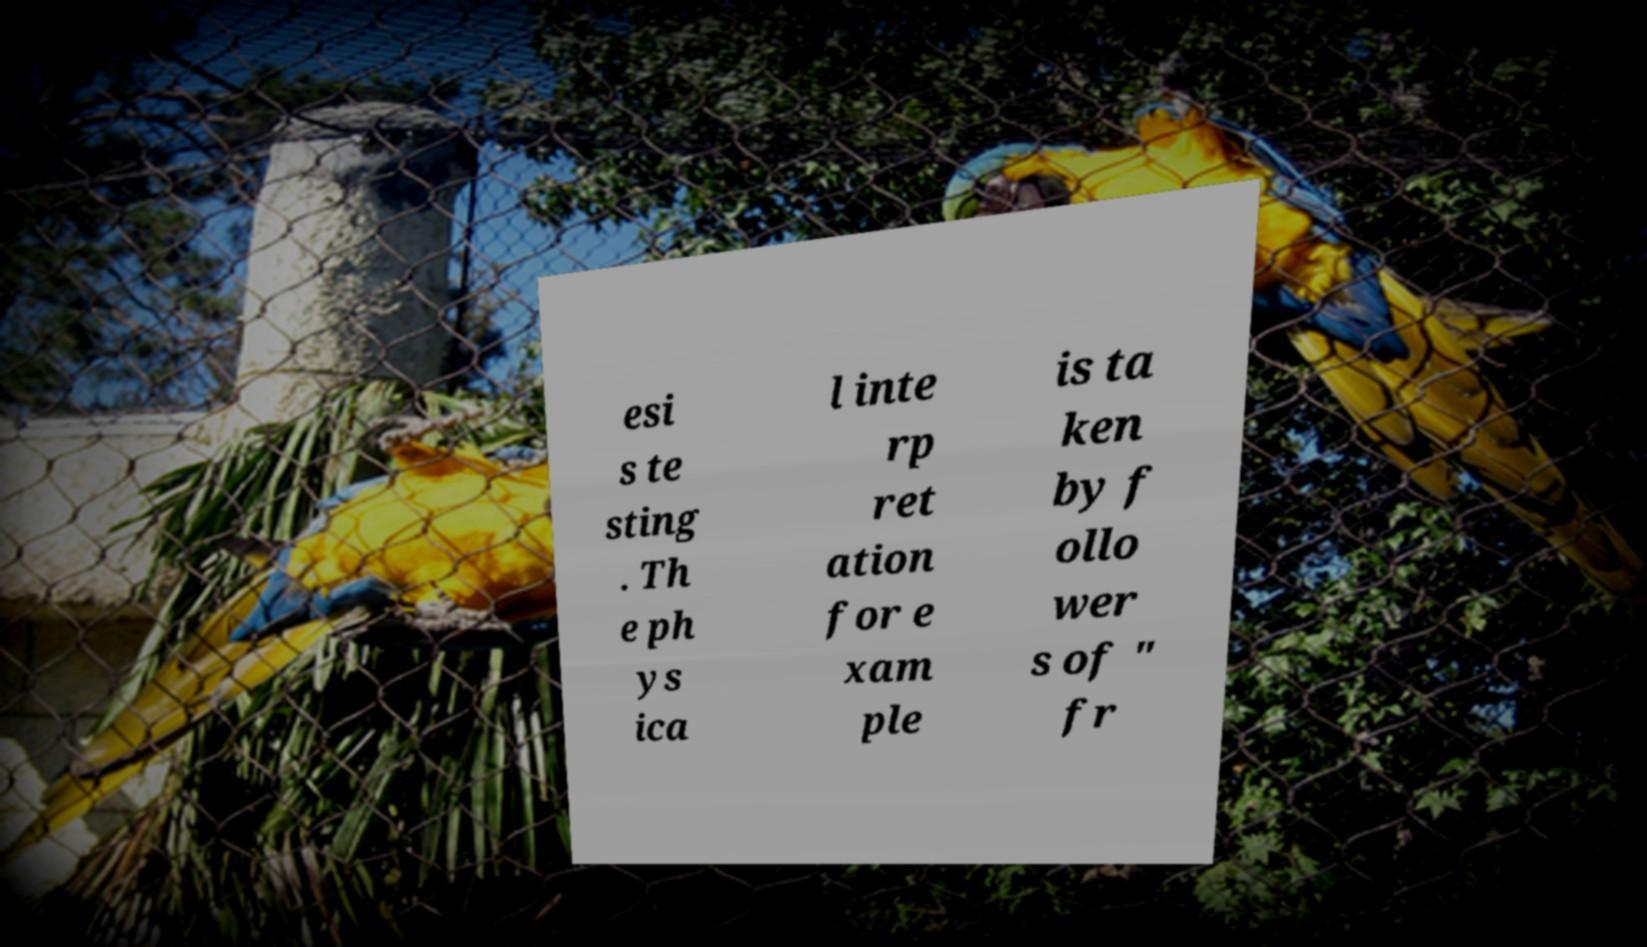Could you assist in decoding the text presented in this image and type it out clearly? esi s te sting . Th e ph ys ica l inte rp ret ation for e xam ple is ta ken by f ollo wer s of " fr 